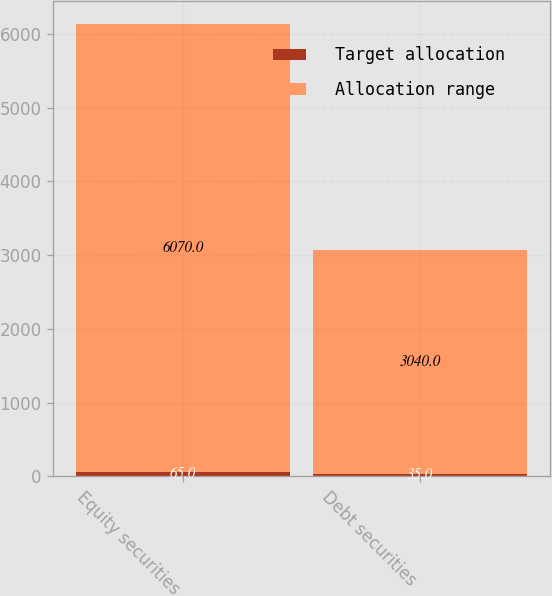<chart> <loc_0><loc_0><loc_500><loc_500><stacked_bar_chart><ecel><fcel>Equity securities<fcel>Debt securities<nl><fcel>Target allocation<fcel>65<fcel>35<nl><fcel>Allocation range<fcel>6070<fcel>3040<nl></chart> 